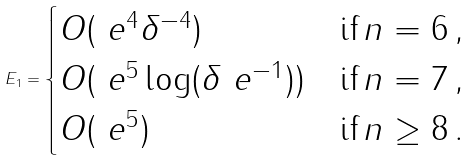<formula> <loc_0><loc_0><loc_500><loc_500>E _ { 1 } = \begin{cases} O ( \ e ^ { 4 } \delta ^ { - 4 } ) & \text {if} \, n = 6 \, , \\ O ( \ e ^ { 5 } \log ( \delta \ e ^ { - 1 } ) ) & \text {if} \, n = 7 \, , \\ O ( \ e ^ { 5 } ) & \text {if} \, n \geq 8 \, . \end{cases}</formula> 